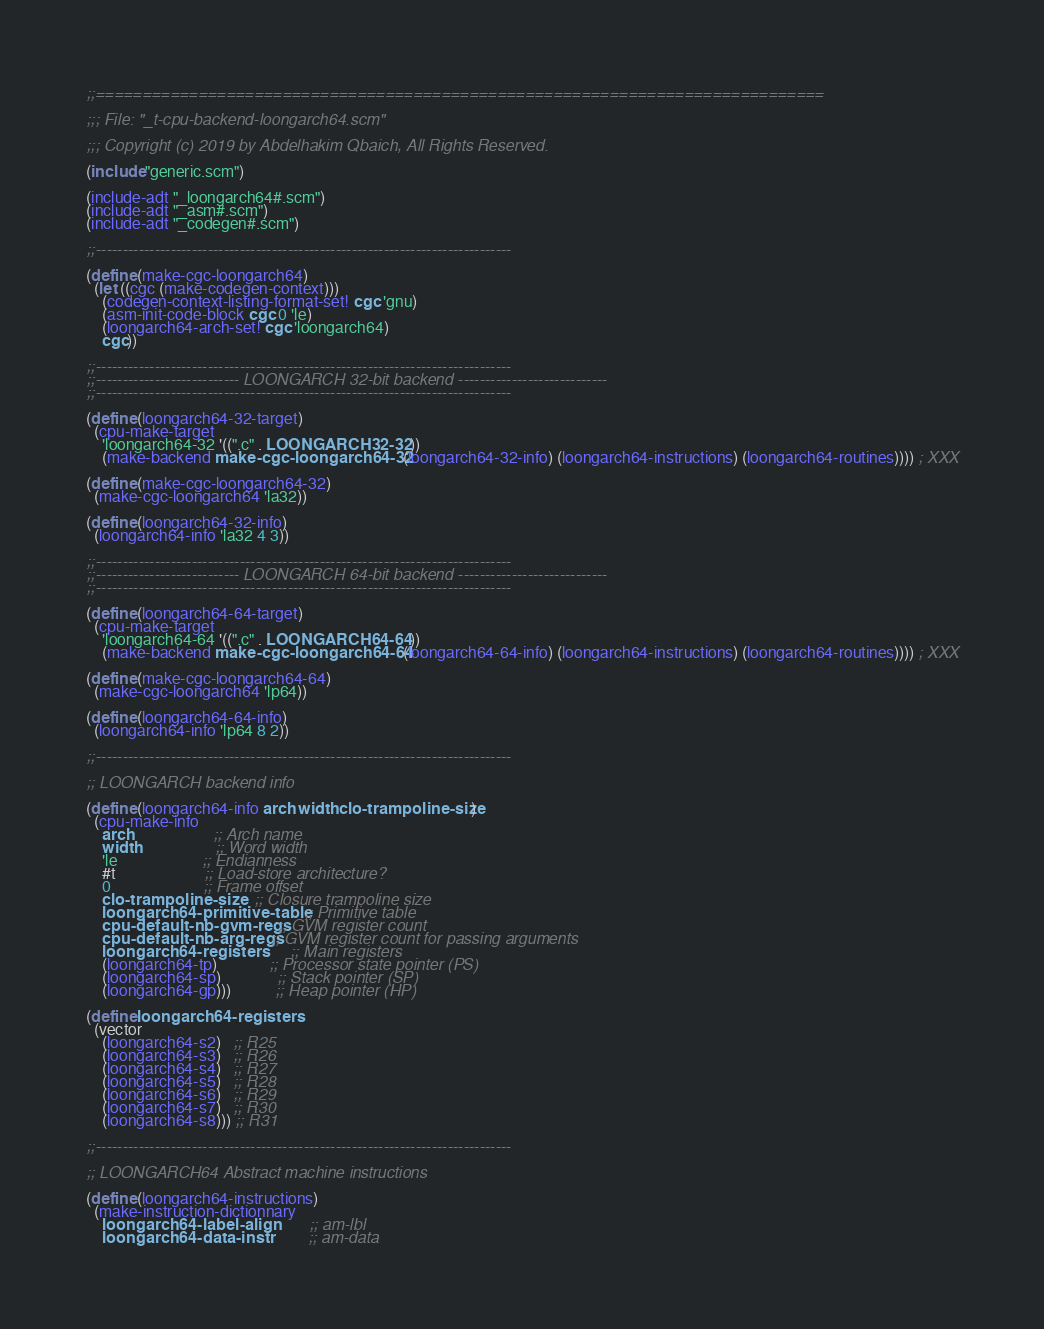<code> <loc_0><loc_0><loc_500><loc_500><_Scheme_>;;==============================================================================

;;; File: "_t-cpu-backend-loongarch64.scm"

;;; Copyright (c) 2019 by Abdelhakim Qbaich, All Rights Reserved.

(include "generic.scm")

(include-adt "_loongarch64#.scm")
(include-adt "_asm#.scm")
(include-adt "_codegen#.scm")

;;------------------------------------------------------------------------------

(define (make-cgc-loongarch64)
  (let ((cgc (make-codegen-context)))
    (codegen-context-listing-format-set! cgc 'gnu)
    (asm-init-code-block cgc 0 'le)
    (loongarch64-arch-set! cgc 'loongarch64)
    cgc))

;;------------------------------------------------------------------------------
;;--------------------------- LOONGARCH 32-bit backend ----------------------------
;;------------------------------------------------------------------------------

(define (loongarch64-32-target)
  (cpu-make-target
    'loongarch64-32 '((".c" . LOONGARCH32-32))
    (make-backend make-cgc-loongarch64-32 (loongarch64-32-info) (loongarch64-instructions) (loongarch64-routines)))) ; XXX

(define (make-cgc-loongarch64-32)
  (make-cgc-loongarch64 'la32))

(define (loongarch64-32-info)
  (loongarch64-info 'la32 4 3))

;;------------------------------------------------------------------------------
;;--------------------------- LOONGARCH 64-bit backend ----------------------------
;;------------------------------------------------------------------------------

(define (loongarch64-64-target)
  (cpu-make-target
    'loongarch64-64 '((".c" . LOONGARCH64-64))
    (make-backend make-cgc-loongarch64-64 (loongarch64-64-info) (loongarch64-instructions) (loongarch64-routines)))) ; XXX

(define (make-cgc-loongarch64-64)
  (make-cgc-loongarch64 'lp64))

(define (loongarch64-64-info)
  (loongarch64-info 'lp64 8 2))

;;------------------------------------------------------------------------------

;; LOONGARCH backend info

(define (loongarch64-info arch width clo-trampoline-size)
  (cpu-make-info
    arch                    ;; Arch name
    width                   ;; Word width
    'le                     ;; Endianness
    #t                      ;; Load-store architecture?
    0                       ;; Frame offset
    clo-trampoline-size     ;; Closure trampoline size
    loongarch64-primitive-table   ;; Primitive table
    cpu-default-nb-gvm-regs ;; GVM register count
    cpu-default-nb-arg-regs ;; GVM register count for passing arguments
    loongarch64-registers         ;; Main registers
    (loongarch64-tp)             ;; Processor state pointer (PS)
    (loongarch64-sp)              ;; Stack pointer (SP)
    (loongarch64-gp)))           ;; Heap pointer (HP)

(define loongarch64-registers
  (vector
    (loongarch64-s2)   ;; R25
    (loongarch64-s3)   ;; R26
    (loongarch64-s4)   ;; R27
    (loongarch64-s5)   ;; R28
    (loongarch64-s6)   ;; R29
    (loongarch64-s7)   ;; R30
    (loongarch64-s8))) ;; R31

;;------------------------------------------------------------------------------

;; LOONGARCH64 Abstract machine instructions

(define (loongarch64-instructions)
  (make-instruction-dictionnary
    loongarch64-label-align           ;; am-lbl
    loongarch64-data-instr            ;; am-data</code> 